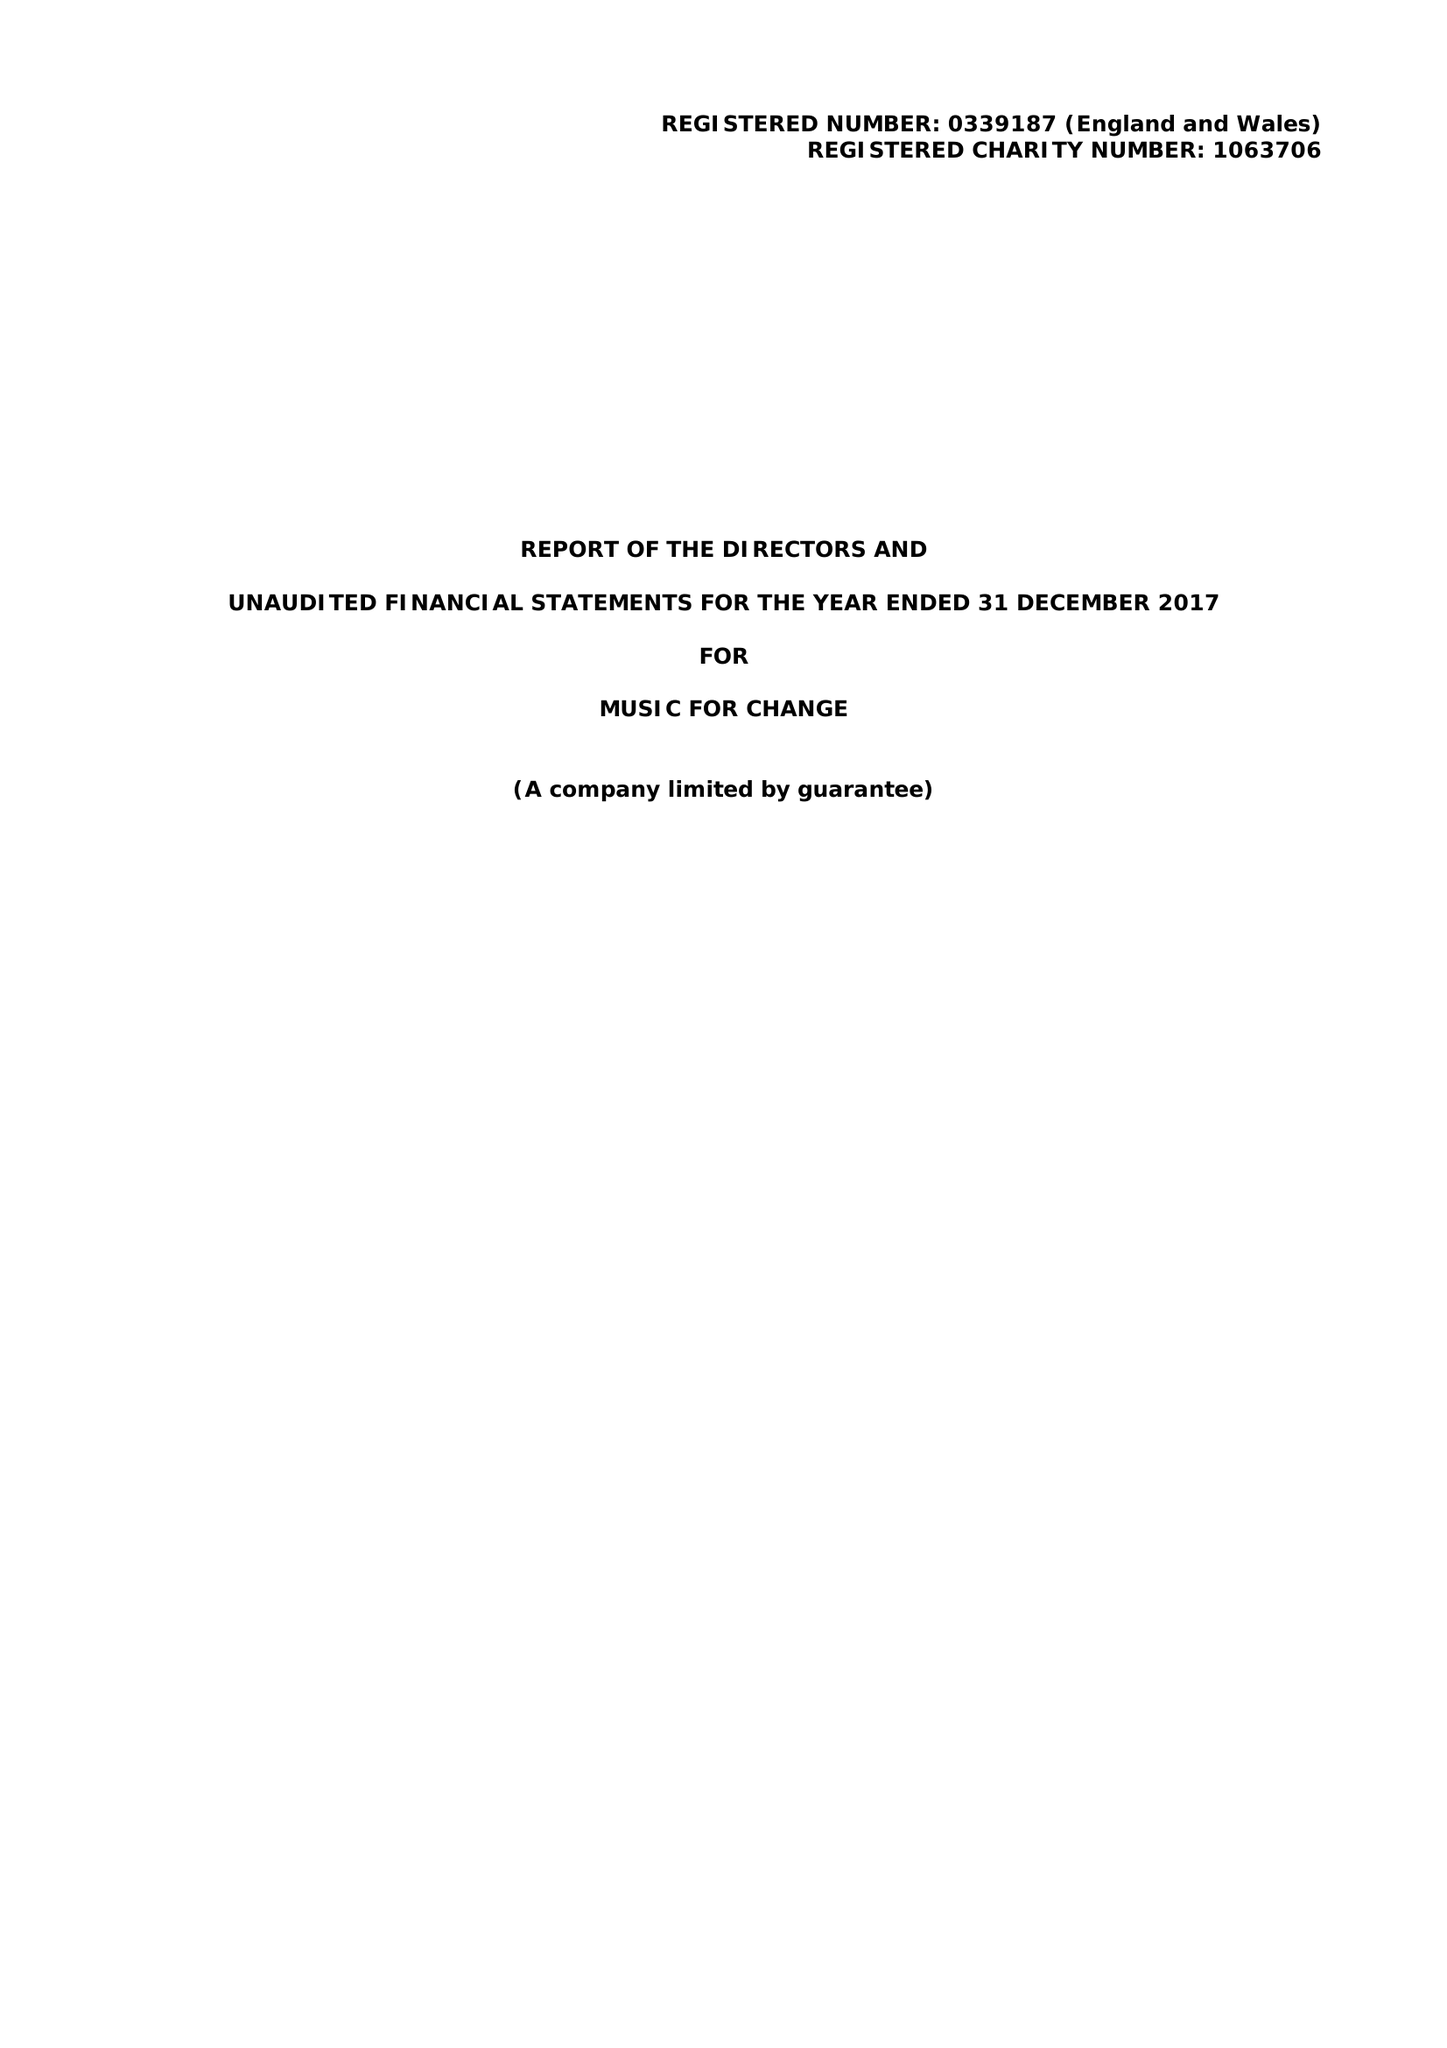What is the value for the charity_number?
Answer the question using a single word or phrase. 1063706 